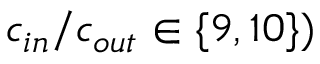Convert formula to latex. <formula><loc_0><loc_0><loc_500><loc_500>c _ { i n } / c _ { o u t } \in \{ 9 , 1 0 \} )</formula> 